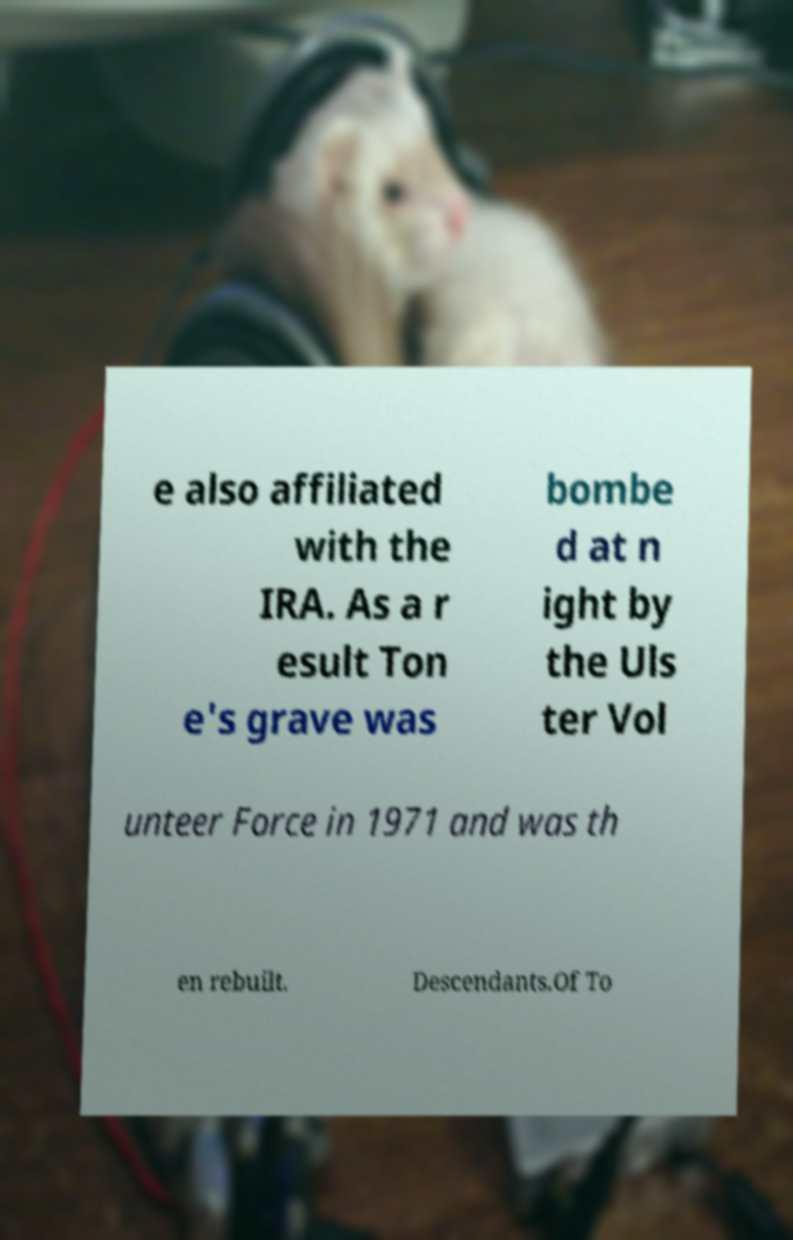For documentation purposes, I need the text within this image transcribed. Could you provide that? e also affiliated with the IRA. As a r esult Ton e's grave was bombe d at n ight by the Uls ter Vol unteer Force in 1971 and was th en rebuilt. Descendants.Of To 